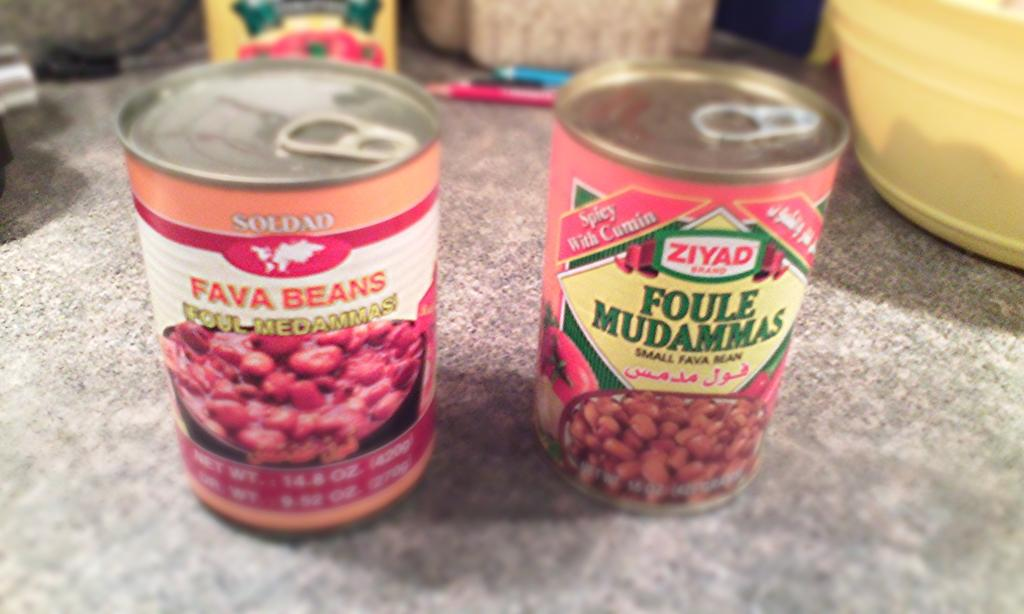<image>
Create a compact narrative representing the image presented. Two cans on a counter say Fava Beans and Foule Mudammas. 